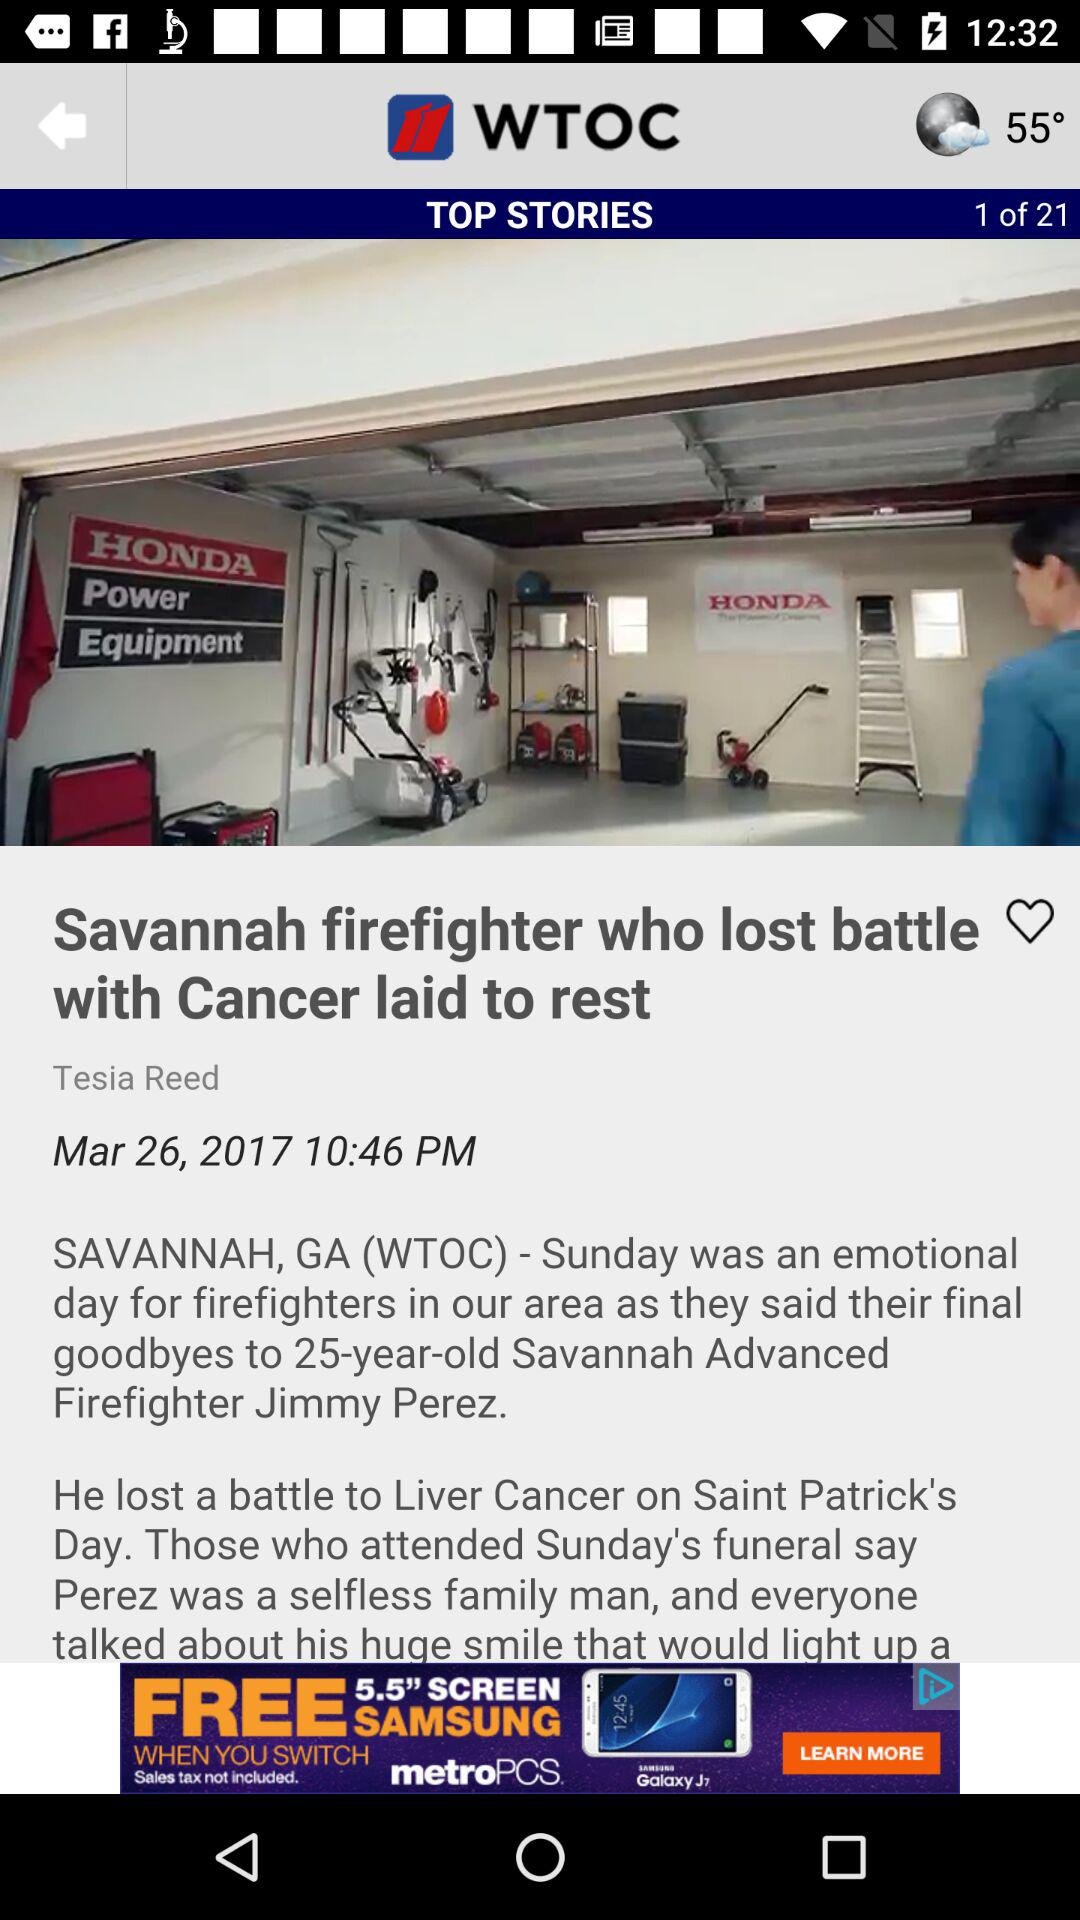Who is the author of the article? The author of the article is Tesia Reed. 